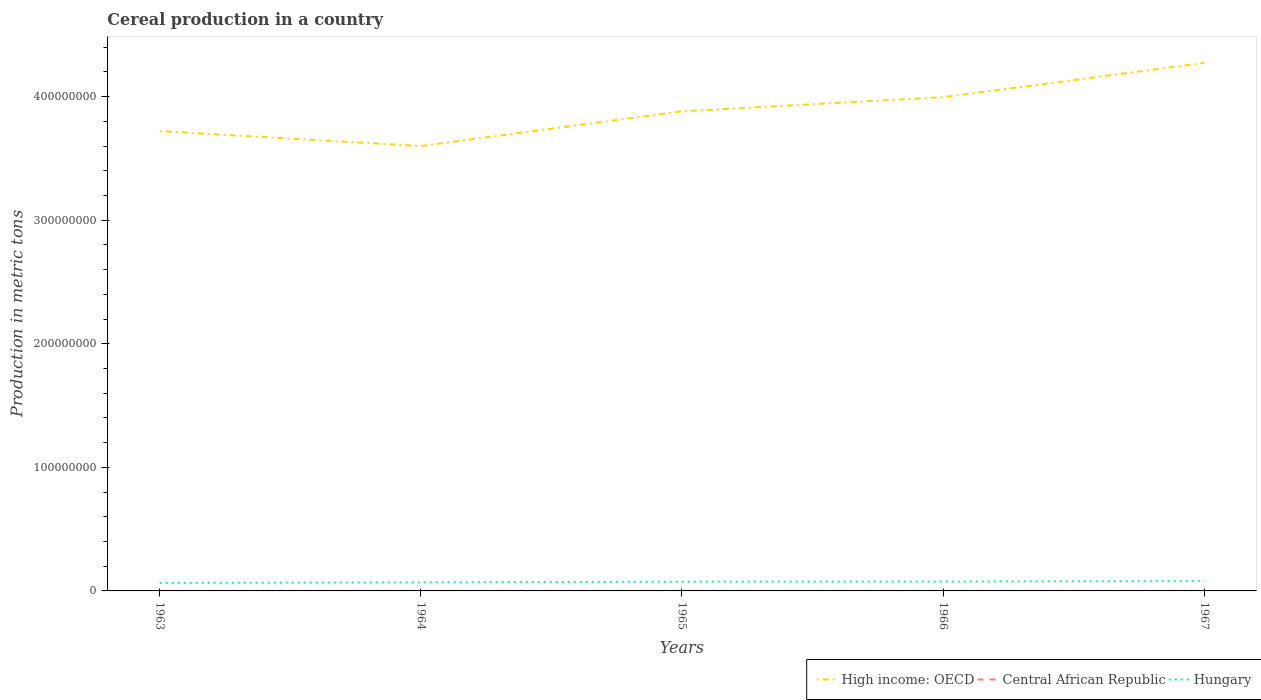How many different coloured lines are there?
Offer a very short reply. 3. Is the number of lines equal to the number of legend labels?
Provide a short and direct response. Yes. Across all years, what is the maximum total cereal production in Hungary?
Provide a short and direct response. 6.48e+06. In which year was the total cereal production in High income: OECD maximum?
Ensure brevity in your answer.  1964. What is the total total cereal production in Hungary in the graph?
Your answer should be compact. -3.12e+05. What is the difference between the highest and the second highest total cereal production in Central African Republic?
Offer a terse response. 5300. What is the difference between the highest and the lowest total cereal production in Hungary?
Offer a very short reply. 3. How many lines are there?
Your answer should be very brief. 3. What is the difference between two consecutive major ticks on the Y-axis?
Make the answer very short. 1.00e+08. Does the graph contain grids?
Offer a terse response. No. Where does the legend appear in the graph?
Your response must be concise. Bottom right. How many legend labels are there?
Your response must be concise. 3. What is the title of the graph?
Your answer should be very brief. Cereal production in a country. What is the label or title of the X-axis?
Your answer should be compact. Years. What is the label or title of the Y-axis?
Make the answer very short. Production in metric tons. What is the Production in metric tons in High income: OECD in 1963?
Offer a terse response. 3.72e+08. What is the Production in metric tons of Central African Republic in 1963?
Give a very brief answer. 8.43e+04. What is the Production in metric tons of Hungary in 1963?
Offer a terse response. 6.48e+06. What is the Production in metric tons of High income: OECD in 1964?
Keep it short and to the point. 3.60e+08. What is the Production in metric tons of Central African Republic in 1964?
Give a very brief answer. 8.70e+04. What is the Production in metric tons in Hungary in 1964?
Offer a very short reply. 6.92e+06. What is the Production in metric tons of High income: OECD in 1965?
Give a very brief answer. 3.88e+08. What is the Production in metric tons of Central African Republic in 1965?
Offer a terse response. 8.85e+04. What is the Production in metric tons of Hungary in 1965?
Ensure brevity in your answer.  7.50e+06. What is the Production in metric tons in High income: OECD in 1966?
Ensure brevity in your answer.  4.00e+08. What is the Production in metric tons in Central African Republic in 1966?
Your answer should be compact. 8.55e+04. What is the Production in metric tons in Hungary in 1966?
Your response must be concise. 7.62e+06. What is the Production in metric tons of High income: OECD in 1967?
Provide a succinct answer. 4.27e+08. What is the Production in metric tons in Central African Republic in 1967?
Keep it short and to the point. 8.96e+04. What is the Production in metric tons in Hungary in 1967?
Your answer should be compact. 7.93e+06. Across all years, what is the maximum Production in metric tons in High income: OECD?
Provide a short and direct response. 4.27e+08. Across all years, what is the maximum Production in metric tons of Central African Republic?
Offer a very short reply. 8.96e+04. Across all years, what is the maximum Production in metric tons in Hungary?
Your answer should be compact. 7.93e+06. Across all years, what is the minimum Production in metric tons in High income: OECD?
Provide a succinct answer. 3.60e+08. Across all years, what is the minimum Production in metric tons of Central African Republic?
Make the answer very short. 8.43e+04. Across all years, what is the minimum Production in metric tons in Hungary?
Offer a terse response. 6.48e+06. What is the total Production in metric tons of High income: OECD in the graph?
Your answer should be compact. 1.95e+09. What is the total Production in metric tons of Central African Republic in the graph?
Provide a succinct answer. 4.35e+05. What is the total Production in metric tons of Hungary in the graph?
Offer a terse response. 3.64e+07. What is the difference between the Production in metric tons of High income: OECD in 1963 and that in 1964?
Your answer should be very brief. 1.20e+07. What is the difference between the Production in metric tons of Central African Republic in 1963 and that in 1964?
Your answer should be compact. -2700. What is the difference between the Production in metric tons in Hungary in 1963 and that in 1964?
Your response must be concise. -4.40e+05. What is the difference between the Production in metric tons of High income: OECD in 1963 and that in 1965?
Your response must be concise. -1.60e+07. What is the difference between the Production in metric tons in Central African Republic in 1963 and that in 1965?
Ensure brevity in your answer.  -4200. What is the difference between the Production in metric tons in Hungary in 1963 and that in 1965?
Make the answer very short. -1.02e+06. What is the difference between the Production in metric tons in High income: OECD in 1963 and that in 1966?
Make the answer very short. -2.75e+07. What is the difference between the Production in metric tons of Central African Republic in 1963 and that in 1966?
Your answer should be compact. -1200. What is the difference between the Production in metric tons in Hungary in 1963 and that in 1966?
Your answer should be very brief. -1.14e+06. What is the difference between the Production in metric tons in High income: OECD in 1963 and that in 1967?
Your answer should be very brief. -5.52e+07. What is the difference between the Production in metric tons of Central African Republic in 1963 and that in 1967?
Your answer should be compact. -5300. What is the difference between the Production in metric tons in Hungary in 1963 and that in 1967?
Ensure brevity in your answer.  -1.45e+06. What is the difference between the Production in metric tons in High income: OECD in 1964 and that in 1965?
Your answer should be compact. -2.81e+07. What is the difference between the Production in metric tons of Central African Republic in 1964 and that in 1965?
Provide a succinct answer. -1500. What is the difference between the Production in metric tons in Hungary in 1964 and that in 1965?
Make the answer very short. -5.77e+05. What is the difference between the Production in metric tons of High income: OECD in 1964 and that in 1966?
Provide a succinct answer. -3.95e+07. What is the difference between the Production in metric tons in Central African Republic in 1964 and that in 1966?
Your answer should be very brief. 1500. What is the difference between the Production in metric tons in Hungary in 1964 and that in 1966?
Your response must be concise. -7.03e+05. What is the difference between the Production in metric tons in High income: OECD in 1964 and that in 1967?
Your answer should be very brief. -6.72e+07. What is the difference between the Production in metric tons in Central African Republic in 1964 and that in 1967?
Give a very brief answer. -2600. What is the difference between the Production in metric tons of Hungary in 1964 and that in 1967?
Provide a succinct answer. -1.01e+06. What is the difference between the Production in metric tons in High income: OECD in 1965 and that in 1966?
Give a very brief answer. -1.15e+07. What is the difference between the Production in metric tons of Central African Republic in 1965 and that in 1966?
Provide a short and direct response. 3000. What is the difference between the Production in metric tons of Hungary in 1965 and that in 1966?
Offer a very short reply. -1.26e+05. What is the difference between the Production in metric tons in High income: OECD in 1965 and that in 1967?
Offer a very short reply. -3.91e+07. What is the difference between the Production in metric tons in Central African Republic in 1965 and that in 1967?
Ensure brevity in your answer.  -1100. What is the difference between the Production in metric tons of Hungary in 1965 and that in 1967?
Your answer should be compact. -4.38e+05. What is the difference between the Production in metric tons of High income: OECD in 1966 and that in 1967?
Make the answer very short. -2.77e+07. What is the difference between the Production in metric tons of Central African Republic in 1966 and that in 1967?
Your response must be concise. -4100. What is the difference between the Production in metric tons of Hungary in 1966 and that in 1967?
Make the answer very short. -3.12e+05. What is the difference between the Production in metric tons of High income: OECD in 1963 and the Production in metric tons of Central African Republic in 1964?
Your answer should be compact. 3.72e+08. What is the difference between the Production in metric tons of High income: OECD in 1963 and the Production in metric tons of Hungary in 1964?
Provide a short and direct response. 3.65e+08. What is the difference between the Production in metric tons of Central African Republic in 1963 and the Production in metric tons of Hungary in 1964?
Keep it short and to the point. -6.83e+06. What is the difference between the Production in metric tons in High income: OECD in 1963 and the Production in metric tons in Central African Republic in 1965?
Your answer should be compact. 3.72e+08. What is the difference between the Production in metric tons in High income: OECD in 1963 and the Production in metric tons in Hungary in 1965?
Offer a terse response. 3.65e+08. What is the difference between the Production in metric tons of Central African Republic in 1963 and the Production in metric tons of Hungary in 1965?
Your answer should be compact. -7.41e+06. What is the difference between the Production in metric tons of High income: OECD in 1963 and the Production in metric tons of Central African Republic in 1966?
Offer a terse response. 3.72e+08. What is the difference between the Production in metric tons in High income: OECD in 1963 and the Production in metric tons in Hungary in 1966?
Your response must be concise. 3.64e+08. What is the difference between the Production in metric tons in Central African Republic in 1963 and the Production in metric tons in Hungary in 1966?
Offer a terse response. -7.54e+06. What is the difference between the Production in metric tons of High income: OECD in 1963 and the Production in metric tons of Central African Republic in 1967?
Provide a short and direct response. 3.72e+08. What is the difference between the Production in metric tons of High income: OECD in 1963 and the Production in metric tons of Hungary in 1967?
Give a very brief answer. 3.64e+08. What is the difference between the Production in metric tons in Central African Republic in 1963 and the Production in metric tons in Hungary in 1967?
Give a very brief answer. -7.85e+06. What is the difference between the Production in metric tons in High income: OECD in 1964 and the Production in metric tons in Central African Republic in 1965?
Provide a short and direct response. 3.60e+08. What is the difference between the Production in metric tons in High income: OECD in 1964 and the Production in metric tons in Hungary in 1965?
Offer a terse response. 3.52e+08. What is the difference between the Production in metric tons of Central African Republic in 1964 and the Production in metric tons of Hungary in 1965?
Your response must be concise. -7.41e+06. What is the difference between the Production in metric tons in High income: OECD in 1964 and the Production in metric tons in Central African Republic in 1966?
Your answer should be very brief. 3.60e+08. What is the difference between the Production in metric tons in High income: OECD in 1964 and the Production in metric tons in Hungary in 1966?
Your response must be concise. 3.52e+08. What is the difference between the Production in metric tons of Central African Republic in 1964 and the Production in metric tons of Hungary in 1966?
Ensure brevity in your answer.  -7.53e+06. What is the difference between the Production in metric tons of High income: OECD in 1964 and the Production in metric tons of Central African Republic in 1967?
Provide a succinct answer. 3.60e+08. What is the difference between the Production in metric tons in High income: OECD in 1964 and the Production in metric tons in Hungary in 1967?
Offer a very short reply. 3.52e+08. What is the difference between the Production in metric tons in Central African Republic in 1964 and the Production in metric tons in Hungary in 1967?
Ensure brevity in your answer.  -7.85e+06. What is the difference between the Production in metric tons of High income: OECD in 1965 and the Production in metric tons of Central African Republic in 1966?
Ensure brevity in your answer.  3.88e+08. What is the difference between the Production in metric tons in High income: OECD in 1965 and the Production in metric tons in Hungary in 1966?
Make the answer very short. 3.80e+08. What is the difference between the Production in metric tons of Central African Republic in 1965 and the Production in metric tons of Hungary in 1966?
Your answer should be very brief. -7.53e+06. What is the difference between the Production in metric tons in High income: OECD in 1965 and the Production in metric tons in Central African Republic in 1967?
Your answer should be very brief. 3.88e+08. What is the difference between the Production in metric tons in High income: OECD in 1965 and the Production in metric tons in Hungary in 1967?
Provide a short and direct response. 3.80e+08. What is the difference between the Production in metric tons of Central African Republic in 1965 and the Production in metric tons of Hungary in 1967?
Your response must be concise. -7.84e+06. What is the difference between the Production in metric tons in High income: OECD in 1966 and the Production in metric tons in Central African Republic in 1967?
Ensure brevity in your answer.  3.99e+08. What is the difference between the Production in metric tons in High income: OECD in 1966 and the Production in metric tons in Hungary in 1967?
Your response must be concise. 3.92e+08. What is the difference between the Production in metric tons in Central African Republic in 1966 and the Production in metric tons in Hungary in 1967?
Your answer should be compact. -7.85e+06. What is the average Production in metric tons in High income: OECD per year?
Make the answer very short. 3.89e+08. What is the average Production in metric tons in Central African Republic per year?
Your answer should be compact. 8.70e+04. What is the average Production in metric tons in Hungary per year?
Keep it short and to the point. 7.29e+06. In the year 1963, what is the difference between the Production in metric tons in High income: OECD and Production in metric tons in Central African Republic?
Provide a short and direct response. 3.72e+08. In the year 1963, what is the difference between the Production in metric tons in High income: OECD and Production in metric tons in Hungary?
Give a very brief answer. 3.66e+08. In the year 1963, what is the difference between the Production in metric tons in Central African Republic and Production in metric tons in Hungary?
Your answer should be very brief. -6.39e+06. In the year 1964, what is the difference between the Production in metric tons of High income: OECD and Production in metric tons of Central African Republic?
Make the answer very short. 3.60e+08. In the year 1964, what is the difference between the Production in metric tons of High income: OECD and Production in metric tons of Hungary?
Your response must be concise. 3.53e+08. In the year 1964, what is the difference between the Production in metric tons in Central African Republic and Production in metric tons in Hungary?
Your answer should be very brief. -6.83e+06. In the year 1965, what is the difference between the Production in metric tons of High income: OECD and Production in metric tons of Central African Republic?
Provide a short and direct response. 3.88e+08. In the year 1965, what is the difference between the Production in metric tons in High income: OECD and Production in metric tons in Hungary?
Provide a succinct answer. 3.81e+08. In the year 1965, what is the difference between the Production in metric tons in Central African Republic and Production in metric tons in Hungary?
Offer a very short reply. -7.41e+06. In the year 1966, what is the difference between the Production in metric tons in High income: OECD and Production in metric tons in Central African Republic?
Keep it short and to the point. 3.99e+08. In the year 1966, what is the difference between the Production in metric tons of High income: OECD and Production in metric tons of Hungary?
Your answer should be very brief. 3.92e+08. In the year 1966, what is the difference between the Production in metric tons of Central African Republic and Production in metric tons of Hungary?
Ensure brevity in your answer.  -7.54e+06. In the year 1967, what is the difference between the Production in metric tons in High income: OECD and Production in metric tons in Central African Republic?
Keep it short and to the point. 4.27e+08. In the year 1967, what is the difference between the Production in metric tons in High income: OECD and Production in metric tons in Hungary?
Your response must be concise. 4.19e+08. In the year 1967, what is the difference between the Production in metric tons of Central African Republic and Production in metric tons of Hungary?
Your response must be concise. -7.84e+06. What is the ratio of the Production in metric tons in High income: OECD in 1963 to that in 1964?
Offer a very short reply. 1.03. What is the ratio of the Production in metric tons of Hungary in 1963 to that in 1964?
Your answer should be compact. 0.94. What is the ratio of the Production in metric tons in High income: OECD in 1963 to that in 1965?
Give a very brief answer. 0.96. What is the ratio of the Production in metric tons in Central African Republic in 1963 to that in 1965?
Your answer should be very brief. 0.95. What is the ratio of the Production in metric tons of Hungary in 1963 to that in 1965?
Provide a short and direct response. 0.86. What is the ratio of the Production in metric tons in High income: OECD in 1963 to that in 1966?
Ensure brevity in your answer.  0.93. What is the ratio of the Production in metric tons of Hungary in 1963 to that in 1966?
Your answer should be very brief. 0.85. What is the ratio of the Production in metric tons of High income: OECD in 1963 to that in 1967?
Your answer should be very brief. 0.87. What is the ratio of the Production in metric tons of Central African Republic in 1963 to that in 1967?
Your answer should be very brief. 0.94. What is the ratio of the Production in metric tons of Hungary in 1963 to that in 1967?
Your answer should be compact. 0.82. What is the ratio of the Production in metric tons in High income: OECD in 1964 to that in 1965?
Give a very brief answer. 0.93. What is the ratio of the Production in metric tons in Central African Republic in 1964 to that in 1965?
Offer a terse response. 0.98. What is the ratio of the Production in metric tons of Hungary in 1964 to that in 1965?
Offer a terse response. 0.92. What is the ratio of the Production in metric tons in High income: OECD in 1964 to that in 1966?
Your response must be concise. 0.9. What is the ratio of the Production in metric tons of Central African Republic in 1964 to that in 1966?
Make the answer very short. 1.02. What is the ratio of the Production in metric tons in Hungary in 1964 to that in 1966?
Make the answer very short. 0.91. What is the ratio of the Production in metric tons in High income: OECD in 1964 to that in 1967?
Your response must be concise. 0.84. What is the ratio of the Production in metric tons in Central African Republic in 1964 to that in 1967?
Your answer should be compact. 0.97. What is the ratio of the Production in metric tons of Hungary in 1964 to that in 1967?
Your response must be concise. 0.87. What is the ratio of the Production in metric tons of High income: OECD in 1965 to that in 1966?
Your response must be concise. 0.97. What is the ratio of the Production in metric tons of Central African Republic in 1965 to that in 1966?
Provide a short and direct response. 1.04. What is the ratio of the Production in metric tons in Hungary in 1965 to that in 1966?
Make the answer very short. 0.98. What is the ratio of the Production in metric tons of High income: OECD in 1965 to that in 1967?
Offer a terse response. 0.91. What is the ratio of the Production in metric tons in Central African Republic in 1965 to that in 1967?
Provide a short and direct response. 0.99. What is the ratio of the Production in metric tons in Hungary in 1965 to that in 1967?
Your answer should be compact. 0.94. What is the ratio of the Production in metric tons in High income: OECD in 1966 to that in 1967?
Offer a terse response. 0.94. What is the ratio of the Production in metric tons of Central African Republic in 1966 to that in 1967?
Your answer should be compact. 0.95. What is the ratio of the Production in metric tons in Hungary in 1966 to that in 1967?
Your answer should be very brief. 0.96. What is the difference between the highest and the second highest Production in metric tons in High income: OECD?
Provide a succinct answer. 2.77e+07. What is the difference between the highest and the second highest Production in metric tons in Central African Republic?
Ensure brevity in your answer.  1100. What is the difference between the highest and the second highest Production in metric tons of Hungary?
Give a very brief answer. 3.12e+05. What is the difference between the highest and the lowest Production in metric tons of High income: OECD?
Keep it short and to the point. 6.72e+07. What is the difference between the highest and the lowest Production in metric tons of Central African Republic?
Provide a succinct answer. 5300. What is the difference between the highest and the lowest Production in metric tons of Hungary?
Give a very brief answer. 1.45e+06. 